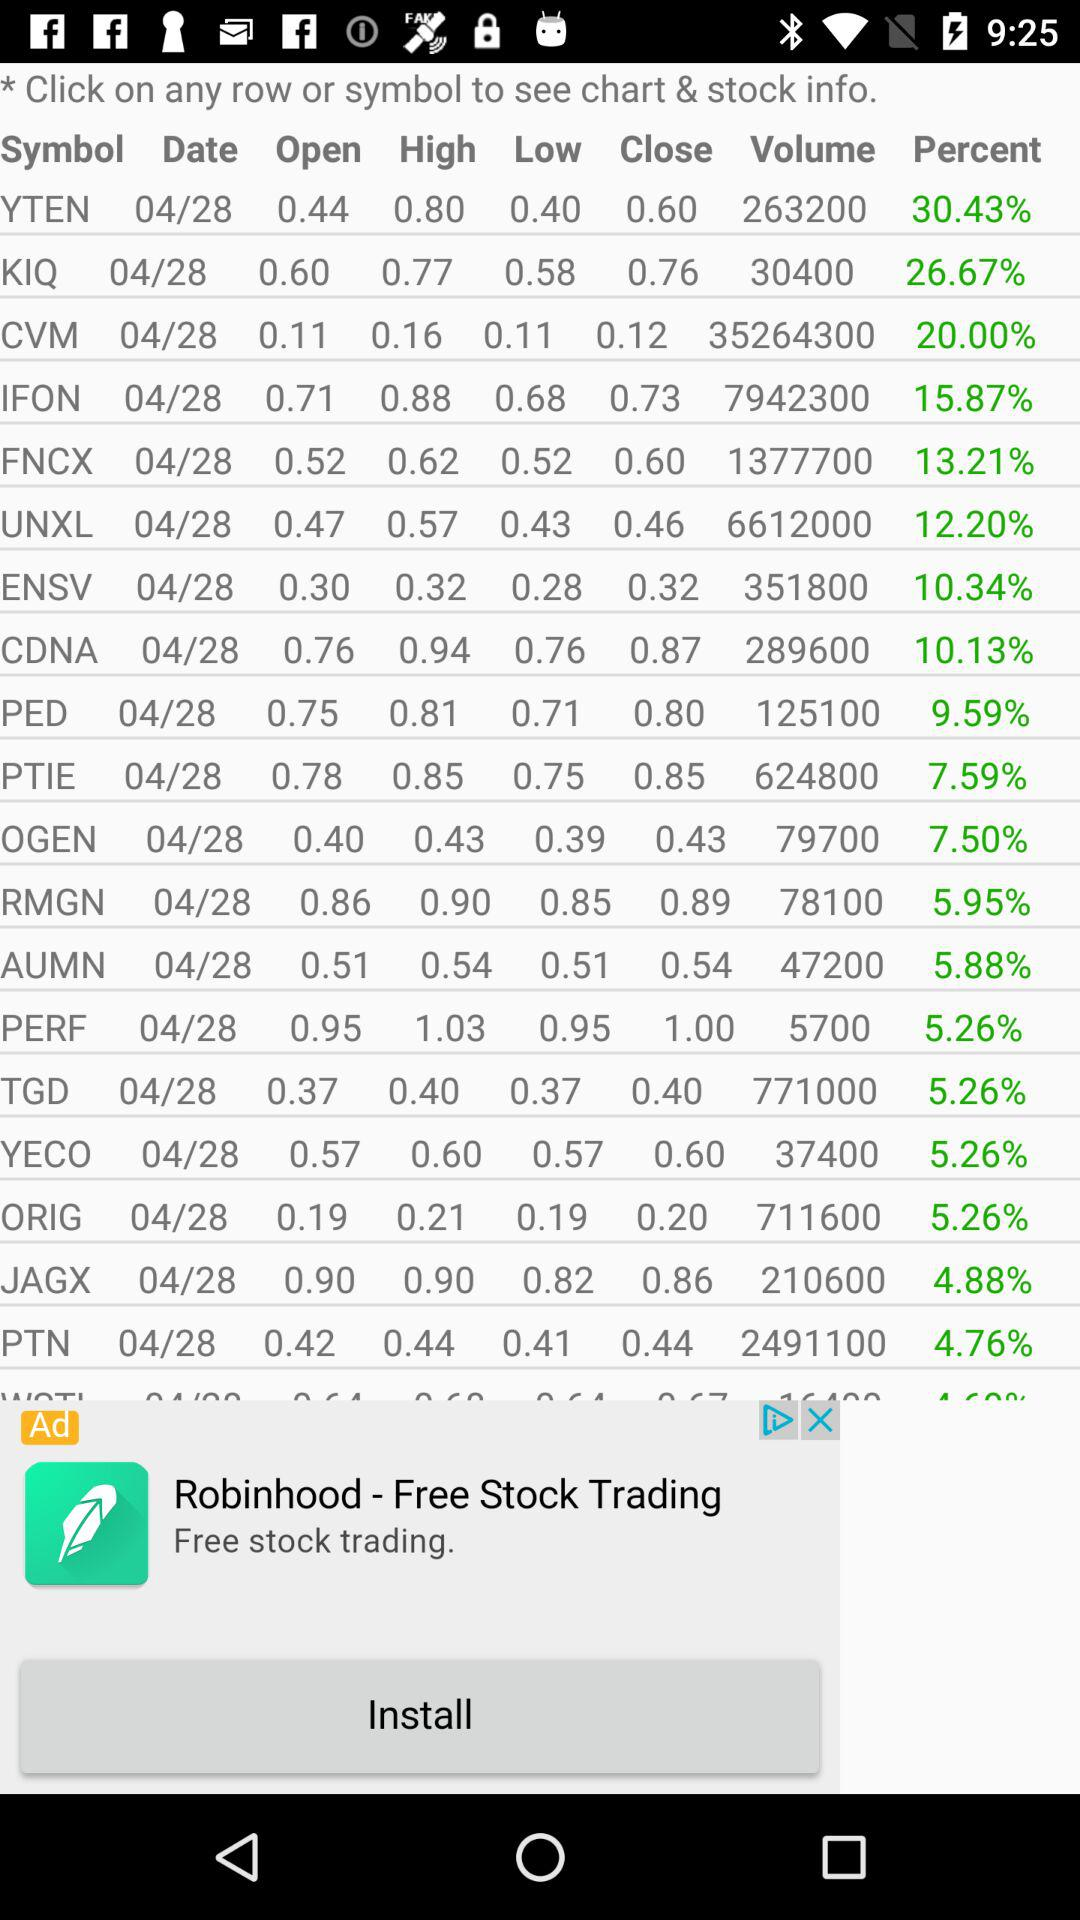What is the stock volume of "YTEN"? The stock volume of "YTEN" is 263200. 